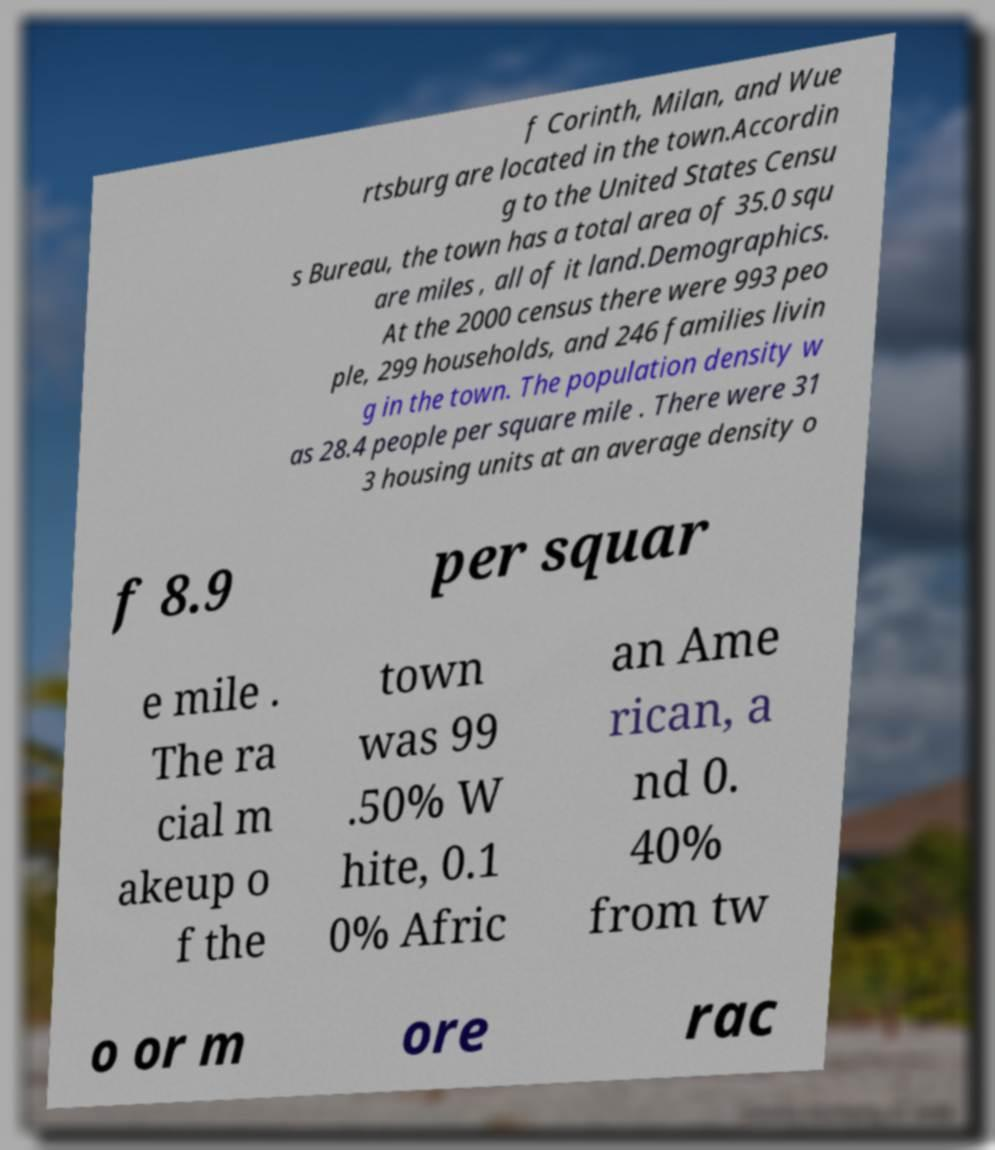What messages or text are displayed in this image? I need them in a readable, typed format. f Corinth, Milan, and Wue rtsburg are located in the town.Accordin g to the United States Censu s Bureau, the town has a total area of 35.0 squ are miles , all of it land.Demographics. At the 2000 census there were 993 peo ple, 299 households, and 246 families livin g in the town. The population density w as 28.4 people per square mile . There were 31 3 housing units at an average density o f 8.9 per squar e mile . The ra cial m akeup o f the town was 99 .50% W hite, 0.1 0% Afric an Ame rican, a nd 0. 40% from tw o or m ore rac 